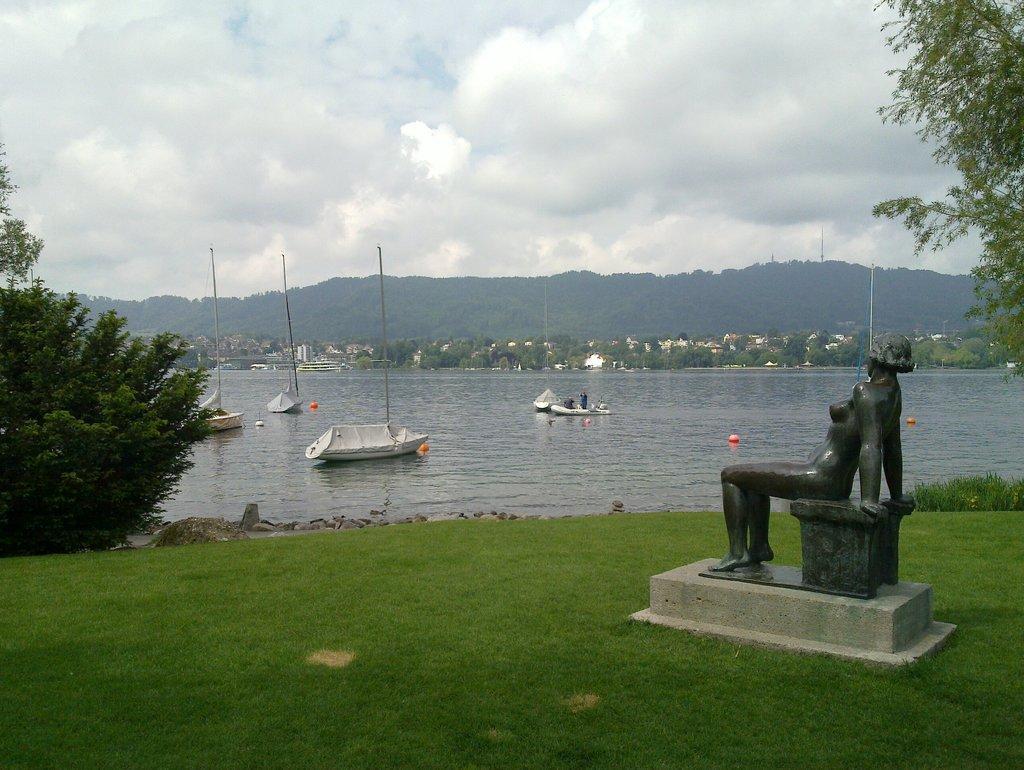How would you summarize this image in a sentence or two? In this image on the right side there is one statue and at the bottom there is grass, on the left side there are some trees and in the center there is one river. In that river there are some boats and in the background there are some mountains and trees, on the top of the image there is sky. 